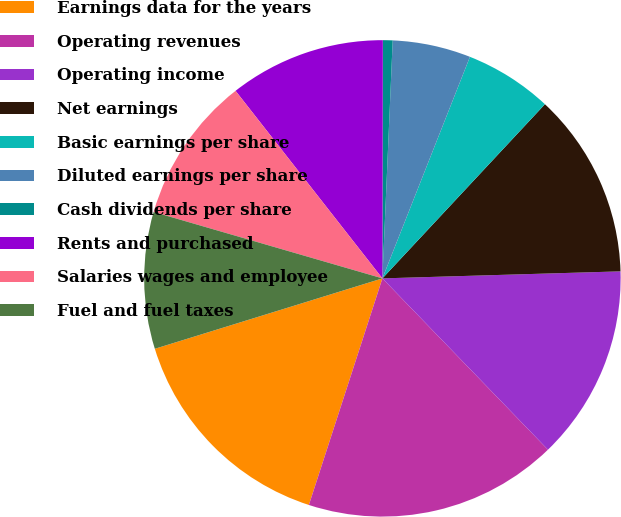<chart> <loc_0><loc_0><loc_500><loc_500><pie_chart><fcel>Earnings data for the years<fcel>Operating revenues<fcel>Operating income<fcel>Net earnings<fcel>Basic earnings per share<fcel>Diluted earnings per share<fcel>Cash dividends per share<fcel>Rents and purchased<fcel>Salaries wages and employee<fcel>Fuel and fuel taxes<nl><fcel>15.23%<fcel>17.22%<fcel>13.24%<fcel>12.58%<fcel>5.96%<fcel>5.3%<fcel>0.66%<fcel>10.6%<fcel>9.93%<fcel>9.27%<nl></chart> 